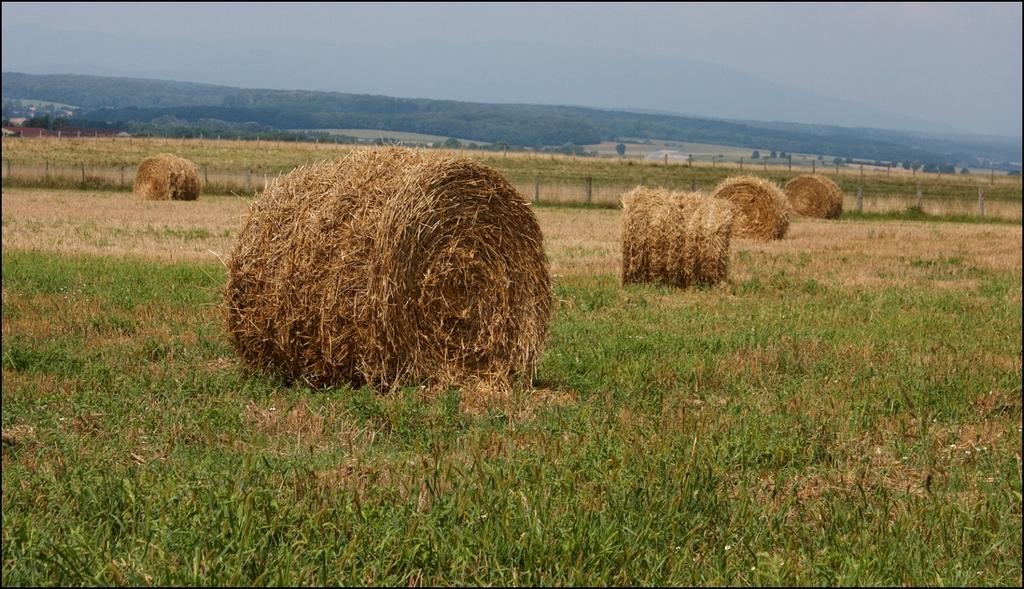What type of vegetation can be seen in the image? There is grass in the image. What structure is present in the image? There is a fence in the image. What other natural elements can be seen in the image? There are trees in the image. What is visible in the background of the image? The sky is visible in the background of the image. Are there any men using a rake in the image? There is no mention of men or a rake in the image; it only features grass, a fence, trees, and the sky. Is the image depicting a winter scene? The image does not indicate a specific season, but there is no snow or ice visible, so it is not a winter scene. 